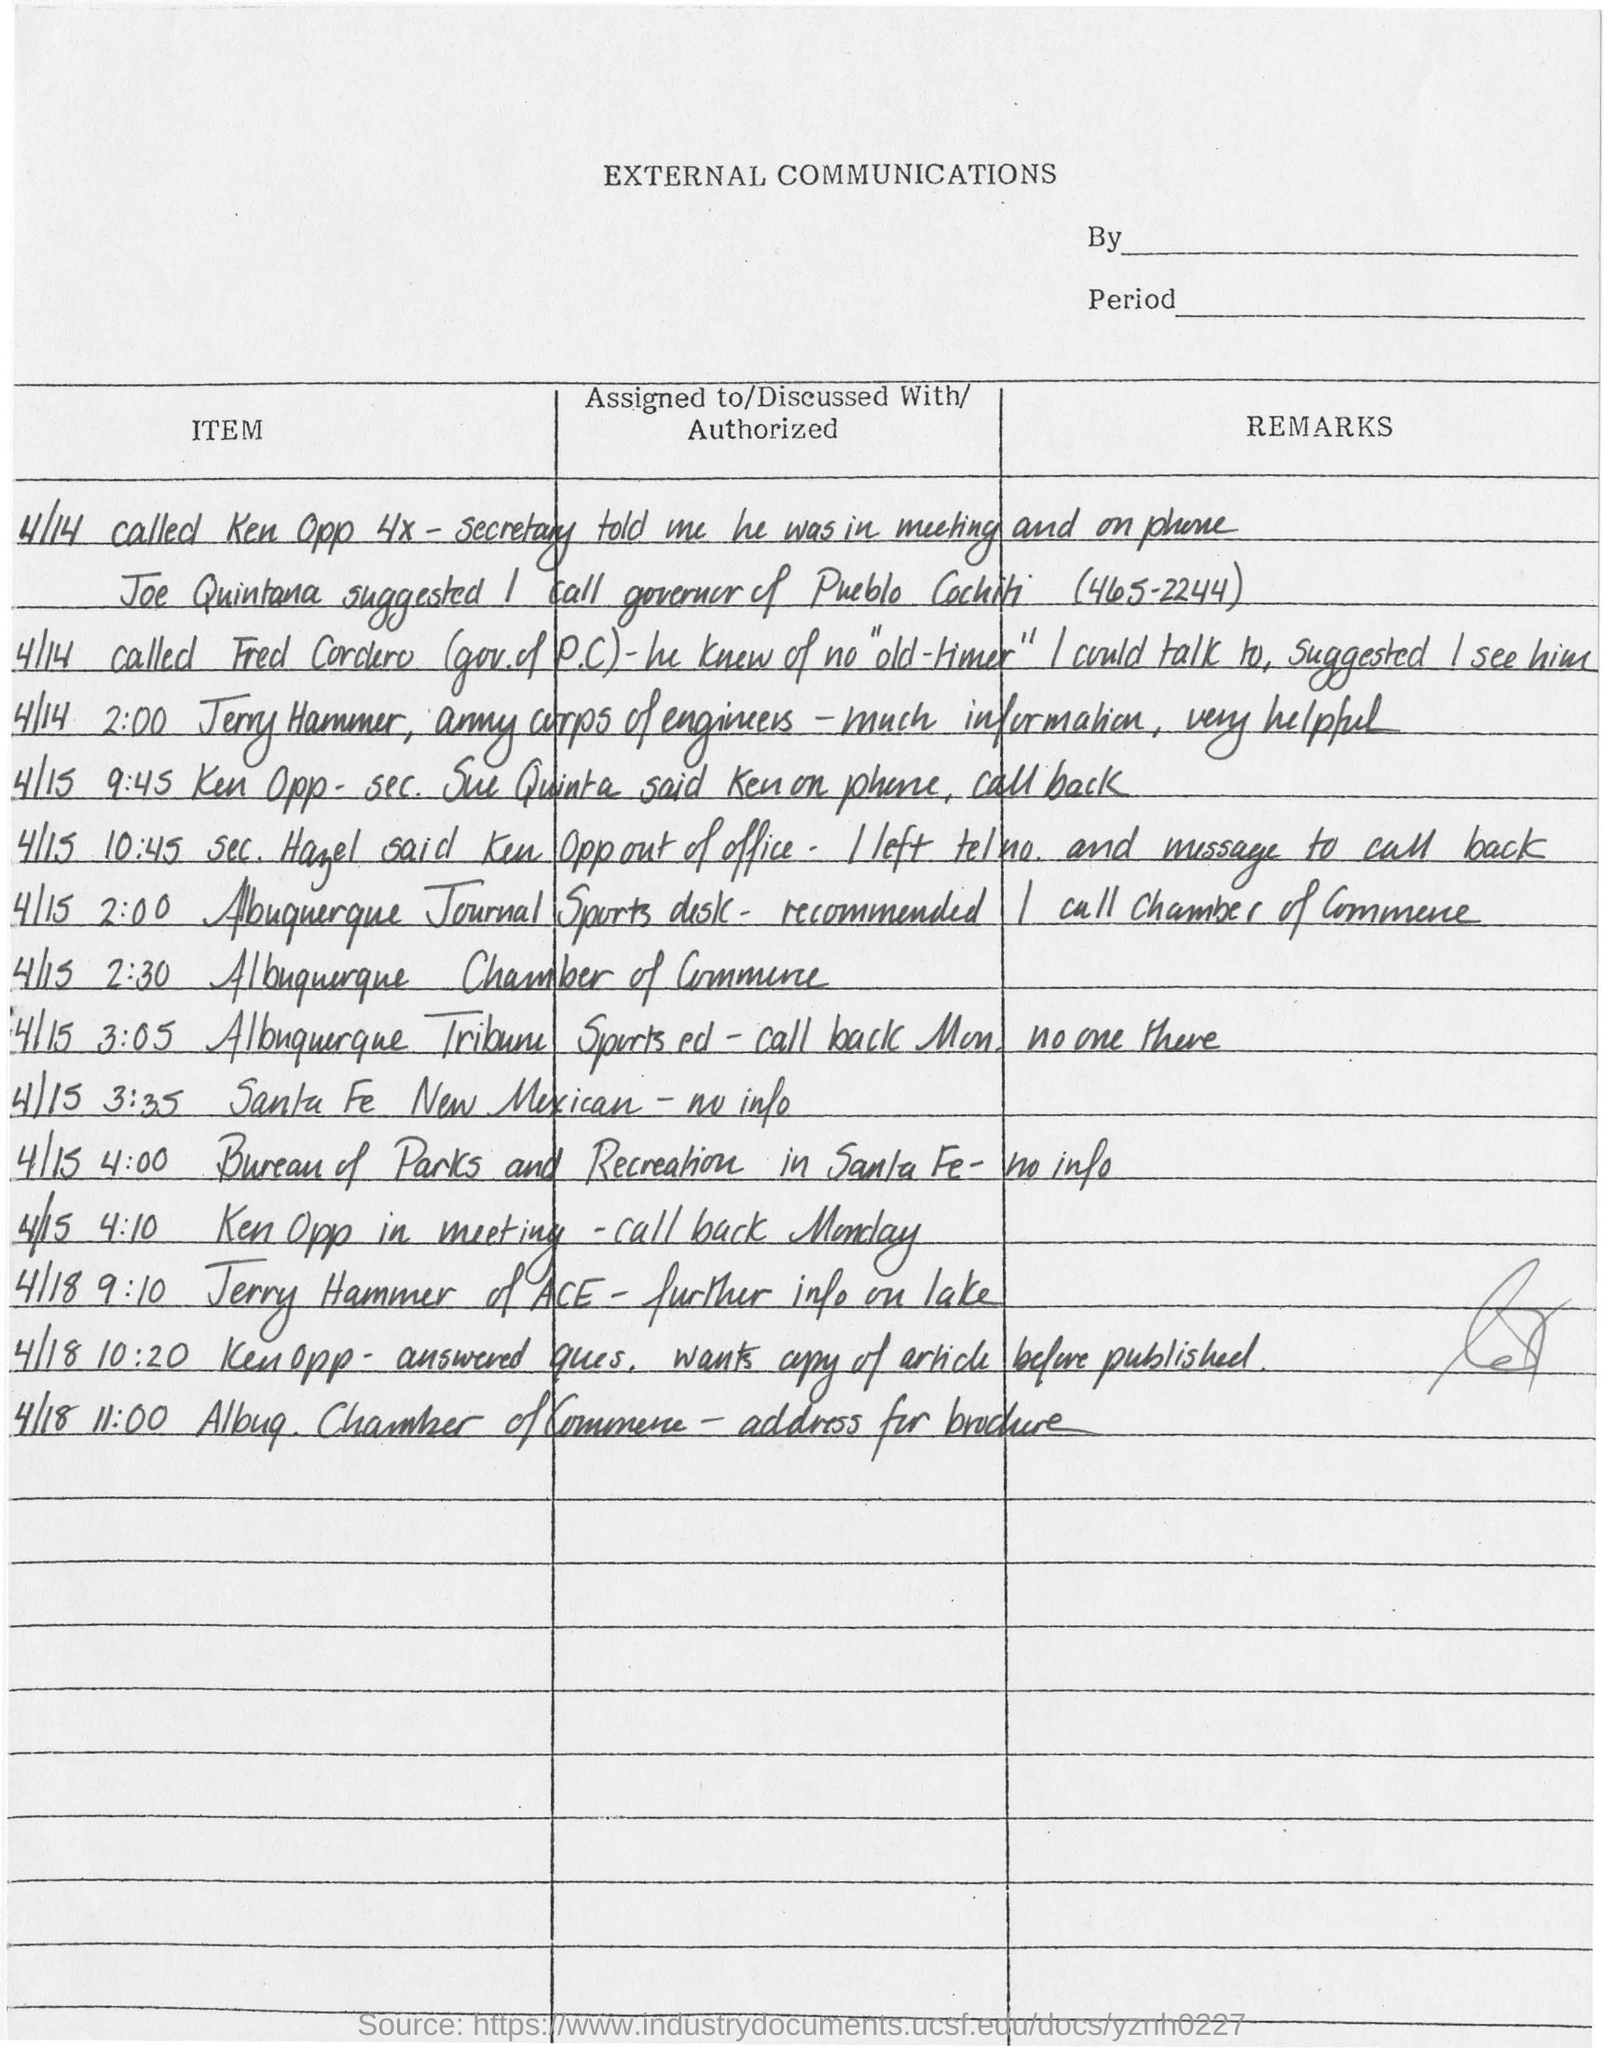Specify some key components in this picture. The document is titled "External Communications. 